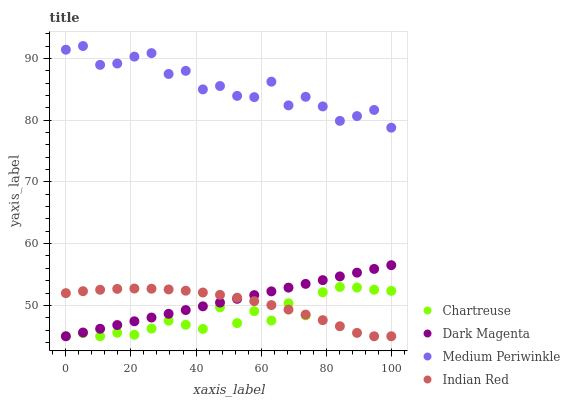Does Chartreuse have the minimum area under the curve?
Answer yes or no. Yes. Does Medium Periwinkle have the maximum area under the curve?
Answer yes or no. Yes. Does Dark Magenta have the minimum area under the curve?
Answer yes or no. No. Does Dark Magenta have the maximum area under the curve?
Answer yes or no. No. Is Dark Magenta the smoothest?
Answer yes or no. Yes. Is Medium Periwinkle the roughest?
Answer yes or no. Yes. Is Medium Periwinkle the smoothest?
Answer yes or no. No. Is Dark Magenta the roughest?
Answer yes or no. No. Does Chartreuse have the lowest value?
Answer yes or no. Yes. Does Medium Periwinkle have the lowest value?
Answer yes or no. No. Does Medium Periwinkle have the highest value?
Answer yes or no. Yes. Does Dark Magenta have the highest value?
Answer yes or no. No. Is Dark Magenta less than Medium Periwinkle?
Answer yes or no. Yes. Is Medium Periwinkle greater than Dark Magenta?
Answer yes or no. Yes. Does Chartreuse intersect Dark Magenta?
Answer yes or no. Yes. Is Chartreuse less than Dark Magenta?
Answer yes or no. No. Is Chartreuse greater than Dark Magenta?
Answer yes or no. No. Does Dark Magenta intersect Medium Periwinkle?
Answer yes or no. No. 